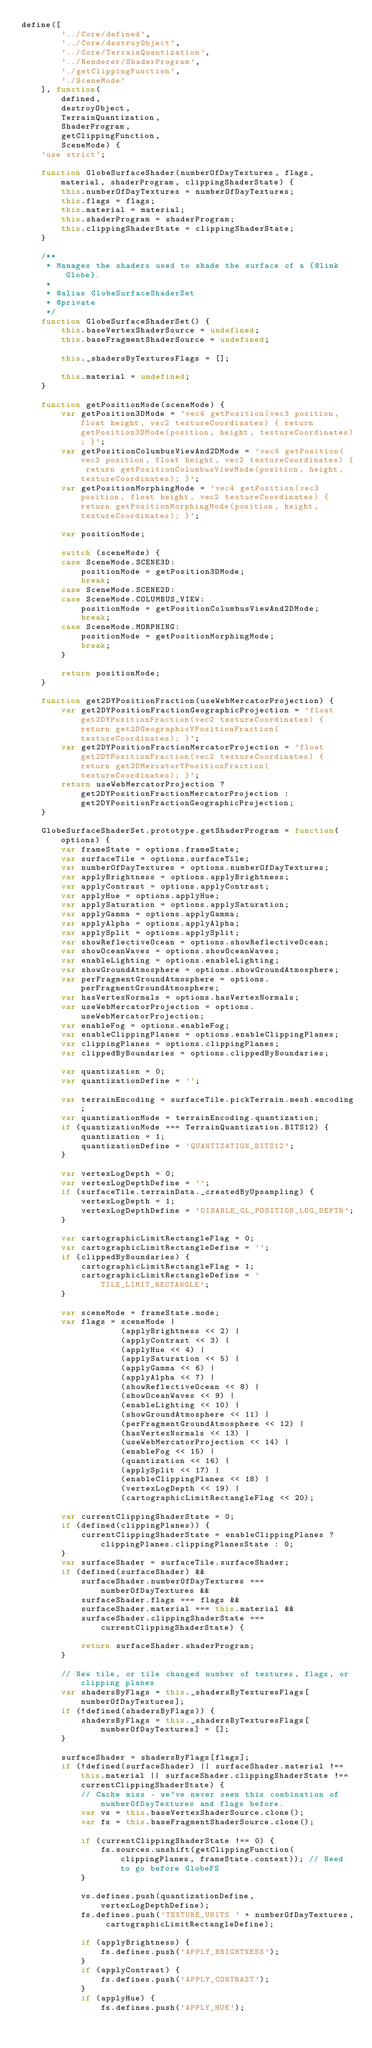Convert code to text. <code><loc_0><loc_0><loc_500><loc_500><_JavaScript_>define([
        '../Core/defined',
        '../Core/destroyObject',
        '../Core/TerrainQuantization',
        '../Renderer/ShaderProgram',
        './getClippingFunction',
        './SceneMode'
    ], function(
        defined,
        destroyObject,
        TerrainQuantization,
        ShaderProgram,
        getClippingFunction,
        SceneMode) {
    'use strict';

    function GlobeSurfaceShader(numberOfDayTextures, flags, material, shaderProgram, clippingShaderState) {
        this.numberOfDayTextures = numberOfDayTextures;
        this.flags = flags;
        this.material = material;
        this.shaderProgram = shaderProgram;
        this.clippingShaderState = clippingShaderState;
    }

    /**
     * Manages the shaders used to shade the surface of a {@link Globe}.
     *
     * @alias GlobeSurfaceShaderSet
     * @private
     */
    function GlobeSurfaceShaderSet() {
        this.baseVertexShaderSource = undefined;
        this.baseFragmentShaderSource = undefined;

        this._shadersByTexturesFlags = [];

        this.material = undefined;
    }

    function getPositionMode(sceneMode) {
        var getPosition3DMode = 'vec4 getPosition(vec3 position, float height, vec2 textureCoordinates) { return getPosition3DMode(position, height, textureCoordinates); }';
        var getPositionColumbusViewAnd2DMode = 'vec4 getPosition(vec3 position, float height, vec2 textureCoordinates) { return getPositionColumbusViewMode(position, height, textureCoordinates); }';
        var getPositionMorphingMode = 'vec4 getPosition(vec3 position, float height, vec2 textureCoordinates) { return getPositionMorphingMode(position, height, textureCoordinates); }';

        var positionMode;

        switch (sceneMode) {
        case SceneMode.SCENE3D:
            positionMode = getPosition3DMode;
            break;
        case SceneMode.SCENE2D:
        case SceneMode.COLUMBUS_VIEW:
            positionMode = getPositionColumbusViewAnd2DMode;
            break;
        case SceneMode.MORPHING:
            positionMode = getPositionMorphingMode;
            break;
        }

        return positionMode;
    }

    function get2DYPositionFraction(useWebMercatorProjection) {
        var get2DYPositionFractionGeographicProjection = 'float get2DYPositionFraction(vec2 textureCoordinates) { return get2DGeographicYPositionFraction(textureCoordinates); }';
        var get2DYPositionFractionMercatorProjection = 'float get2DYPositionFraction(vec2 textureCoordinates) { return get2DMercatorYPositionFraction(textureCoordinates); }';
        return useWebMercatorProjection ? get2DYPositionFractionMercatorProjection : get2DYPositionFractionGeographicProjection;
    }

    GlobeSurfaceShaderSet.prototype.getShaderProgram = function(options) {
        var frameState = options.frameState;
        var surfaceTile = options.surfaceTile;
        var numberOfDayTextures = options.numberOfDayTextures;
        var applyBrightness = options.applyBrightness;
        var applyContrast = options.applyContrast;
        var applyHue = options.applyHue;
        var applySaturation = options.applySaturation;
        var applyGamma = options.applyGamma;
        var applyAlpha = options.applyAlpha;
        var applySplit = options.applySplit;
        var showReflectiveOcean = options.showReflectiveOcean;
        var showOceanWaves = options.showOceanWaves;
        var enableLighting = options.enableLighting;
        var showGroundAtmosphere = options.showGroundAtmosphere;
        var perFragmentGroundAtmosphere = options.perFragmentGroundAtmosphere;
        var hasVertexNormals = options.hasVertexNormals;
        var useWebMercatorProjection = options.useWebMercatorProjection;
        var enableFog = options.enableFog;
        var enableClippingPlanes = options.enableClippingPlanes;
        var clippingPlanes = options.clippingPlanes;
        var clippedByBoundaries = options.clippedByBoundaries;

        var quantization = 0;
        var quantizationDefine = '';

        var terrainEncoding = surfaceTile.pickTerrain.mesh.encoding;
        var quantizationMode = terrainEncoding.quantization;
        if (quantizationMode === TerrainQuantization.BITS12) {
            quantization = 1;
            quantizationDefine = 'QUANTIZATION_BITS12';
        }

        var vertexLogDepth = 0;
        var vertexLogDepthDefine = '';
        if (surfaceTile.terrainData._createdByUpsampling) {
            vertexLogDepth = 1;
            vertexLogDepthDefine = 'DISABLE_GL_POSITION_LOG_DEPTH';
        }

        var cartographicLimitRectangleFlag = 0;
        var cartographicLimitRectangleDefine = '';
        if (clippedByBoundaries) {
            cartographicLimitRectangleFlag = 1;
            cartographicLimitRectangleDefine = 'TILE_LIMIT_RECTANGLE';
        }

        var sceneMode = frameState.mode;
        var flags = sceneMode |
                    (applyBrightness << 2) |
                    (applyContrast << 3) |
                    (applyHue << 4) |
                    (applySaturation << 5) |
                    (applyGamma << 6) |
                    (applyAlpha << 7) |
                    (showReflectiveOcean << 8) |
                    (showOceanWaves << 9) |
                    (enableLighting << 10) |
                    (showGroundAtmosphere << 11) |
                    (perFragmentGroundAtmosphere << 12) |
                    (hasVertexNormals << 13) |
                    (useWebMercatorProjection << 14) |
                    (enableFog << 15) |
                    (quantization << 16) |
                    (applySplit << 17) |
                    (enableClippingPlanes << 18) |
                    (vertexLogDepth << 19) |
                    (cartographicLimitRectangleFlag << 20);

        var currentClippingShaderState = 0;
        if (defined(clippingPlanes)) {
            currentClippingShaderState = enableClippingPlanes ? clippingPlanes.clippingPlanesState : 0;
        }
        var surfaceShader = surfaceTile.surfaceShader;
        if (defined(surfaceShader) &&
            surfaceShader.numberOfDayTextures === numberOfDayTextures &&
            surfaceShader.flags === flags &&
            surfaceShader.material === this.material &&
            surfaceShader.clippingShaderState === currentClippingShaderState) {

            return surfaceShader.shaderProgram;
        }

        // New tile, or tile changed number of textures, flags, or clipping planes
        var shadersByFlags = this._shadersByTexturesFlags[numberOfDayTextures];
        if (!defined(shadersByFlags)) {
            shadersByFlags = this._shadersByTexturesFlags[numberOfDayTextures] = [];
        }

        surfaceShader = shadersByFlags[flags];
        if (!defined(surfaceShader) || surfaceShader.material !== this.material || surfaceShader.clippingShaderState !== currentClippingShaderState) {
            // Cache miss - we've never seen this combination of numberOfDayTextures and flags before.
            var vs = this.baseVertexShaderSource.clone();
            var fs = this.baseFragmentShaderSource.clone();

            if (currentClippingShaderState !== 0) {
                fs.sources.unshift(getClippingFunction(clippingPlanes, frameState.context)); // Need to go before GlobeFS
            }

            vs.defines.push(quantizationDefine, vertexLogDepthDefine);
            fs.defines.push('TEXTURE_UNITS ' + numberOfDayTextures, cartographicLimitRectangleDefine);

            if (applyBrightness) {
                fs.defines.push('APPLY_BRIGHTNESS');
            }
            if (applyContrast) {
                fs.defines.push('APPLY_CONTRAST');
            }
            if (applyHue) {
                fs.defines.push('APPLY_HUE');</code> 